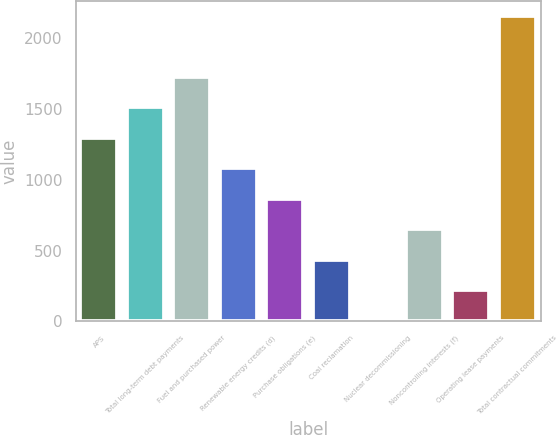Convert chart to OTSL. <chart><loc_0><loc_0><loc_500><loc_500><bar_chart><fcel>APS<fcel>Total long-term debt payments<fcel>Fuel and purchased power<fcel>Renewable energy credits (d)<fcel>Purchase obligations (e)<fcel>Coal reclamation<fcel>Nuclear decommissioning<fcel>Noncontrolling interests (f)<fcel>Operating lease payments<fcel>Total contractual commitments<nl><fcel>1297.4<fcel>1512.8<fcel>1728.2<fcel>1082<fcel>866.6<fcel>435.8<fcel>5<fcel>651.2<fcel>220.4<fcel>2159<nl></chart> 